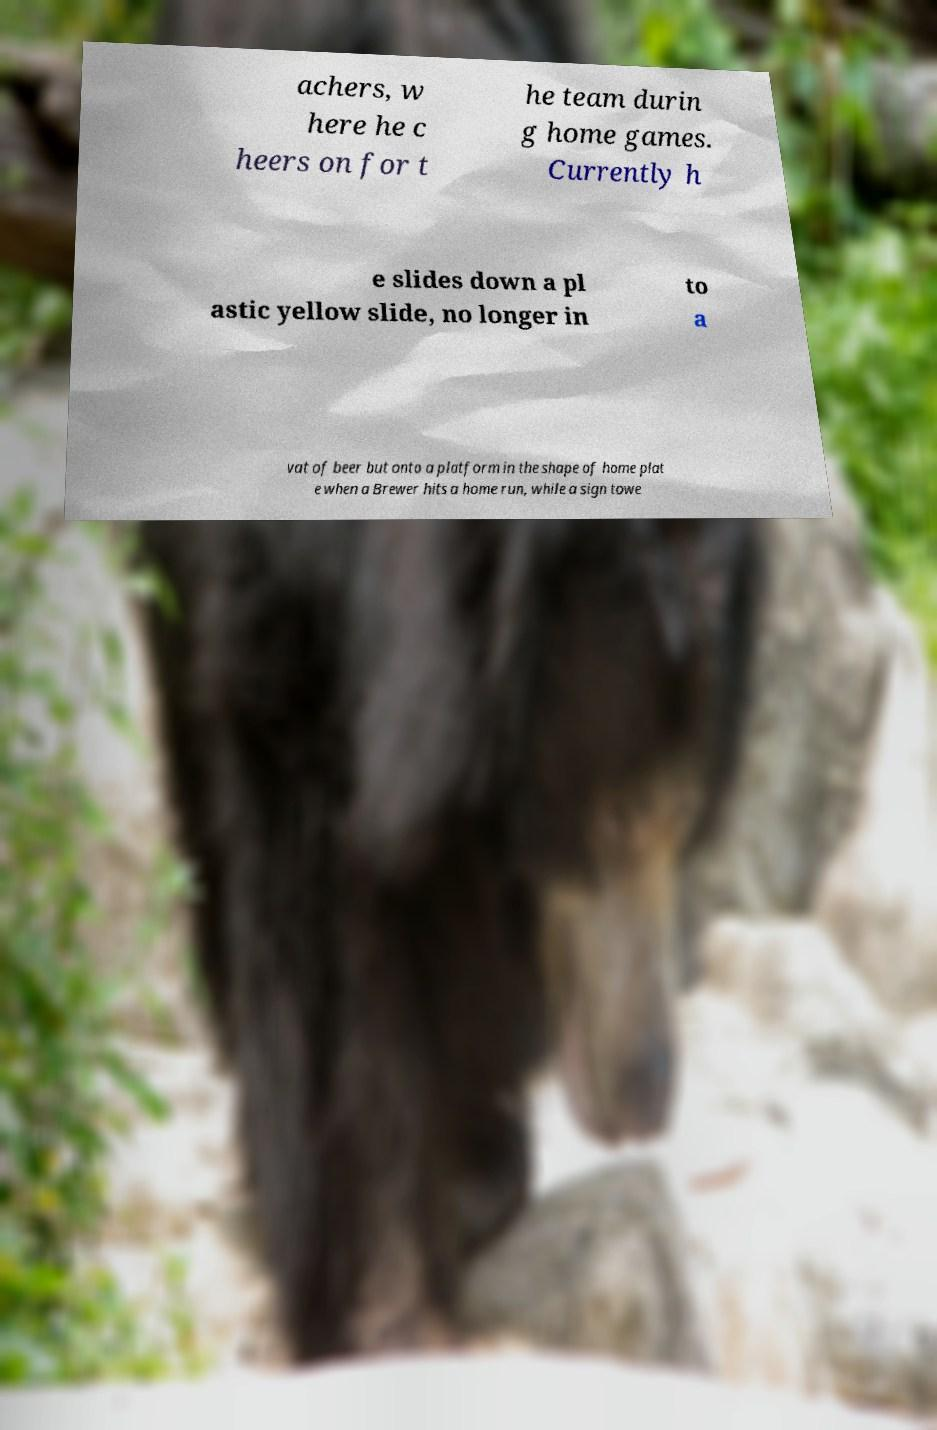Could you assist in decoding the text presented in this image and type it out clearly? achers, w here he c heers on for t he team durin g home games. Currently h e slides down a pl astic yellow slide, no longer in to a vat of beer but onto a platform in the shape of home plat e when a Brewer hits a home run, while a sign towe 